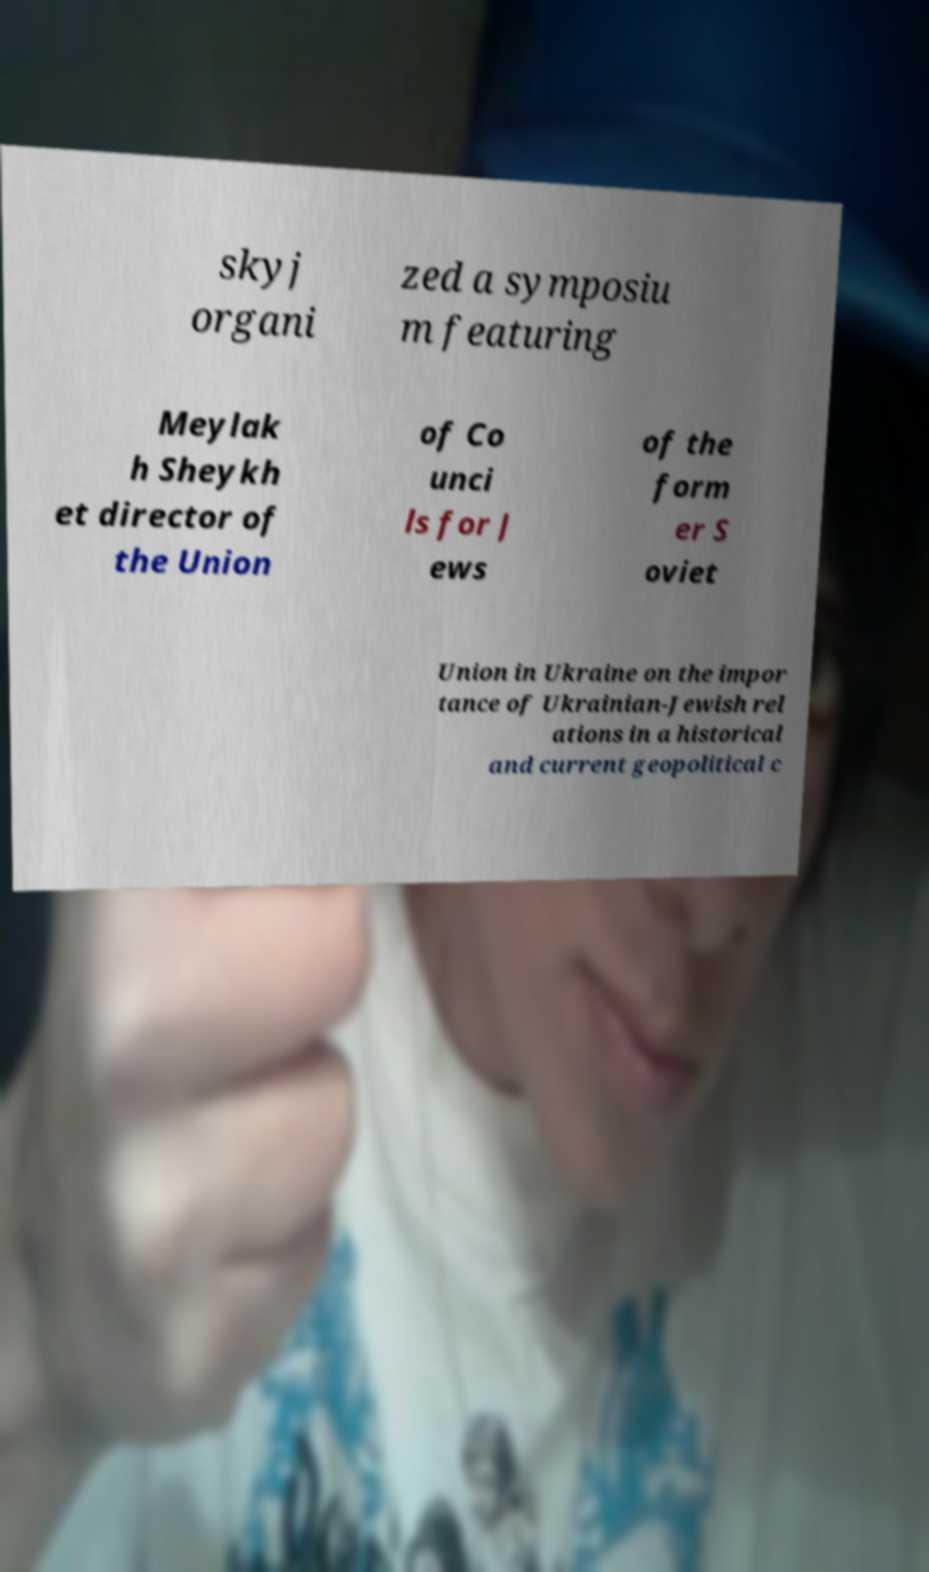Could you extract and type out the text from this image? skyj organi zed a symposiu m featuring Meylak h Sheykh et director of the Union of Co unci ls for J ews of the form er S oviet Union in Ukraine on the impor tance of Ukrainian-Jewish rel ations in a historical and current geopolitical c 